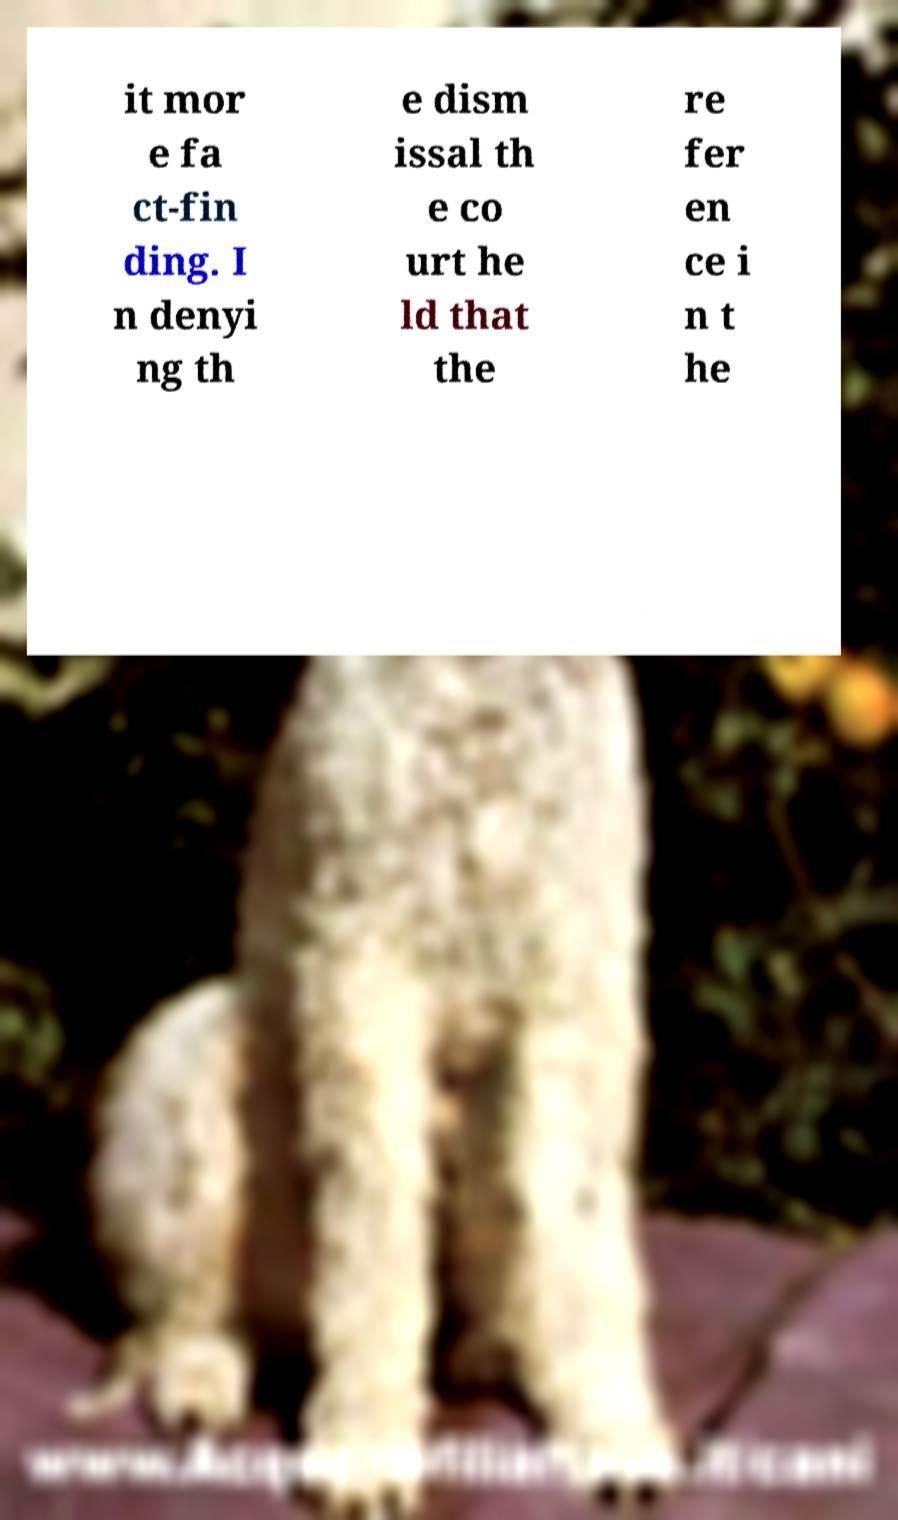Please read and relay the text visible in this image. What does it say? it mor e fa ct-fin ding. I n denyi ng th e dism issal th e co urt he ld that the re fer en ce i n t he 